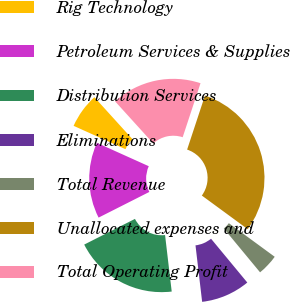Convert chart. <chart><loc_0><loc_0><loc_500><loc_500><pie_chart><fcel>Rig Technology<fcel>Petroleum Services & Supplies<fcel>Distribution Services<fcel>Eliminations<fcel>Total Revenue<fcel>Unallocated expenses and<fcel>Total Operating Profit<nl><fcel>6.54%<fcel>14.19%<fcel>19.41%<fcel>9.14%<fcel>3.93%<fcel>29.99%<fcel>16.8%<nl></chart> 